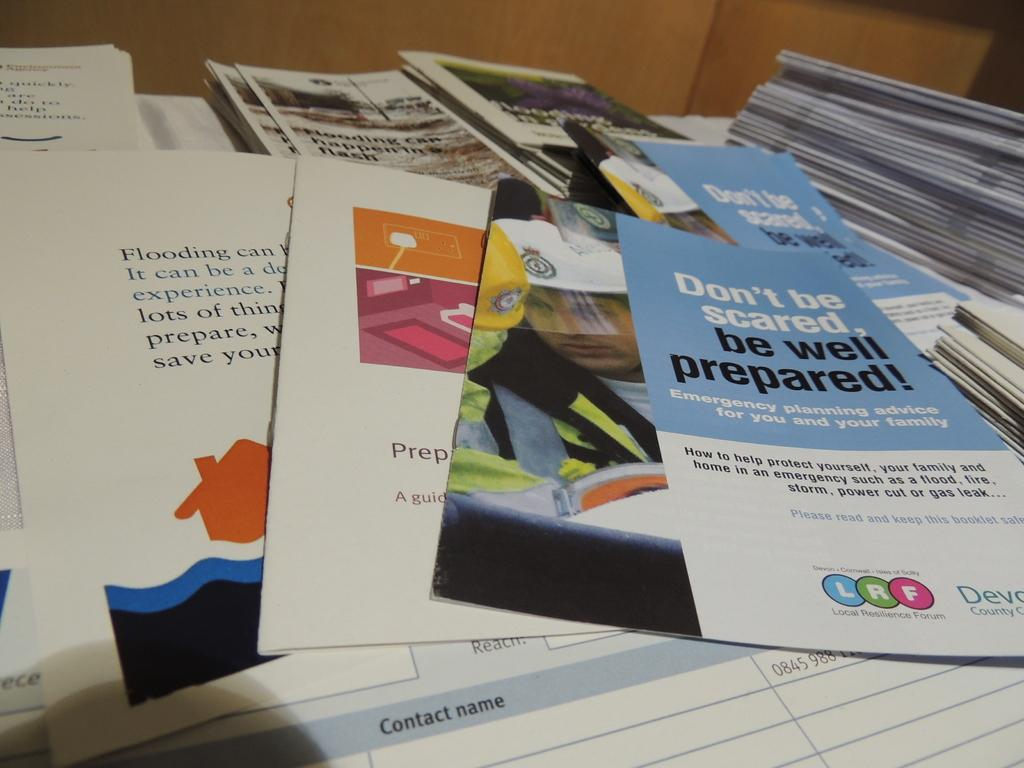<image>
Write a terse but informative summary of the picture. a bunch of pamphlets one on the right about  being well. 